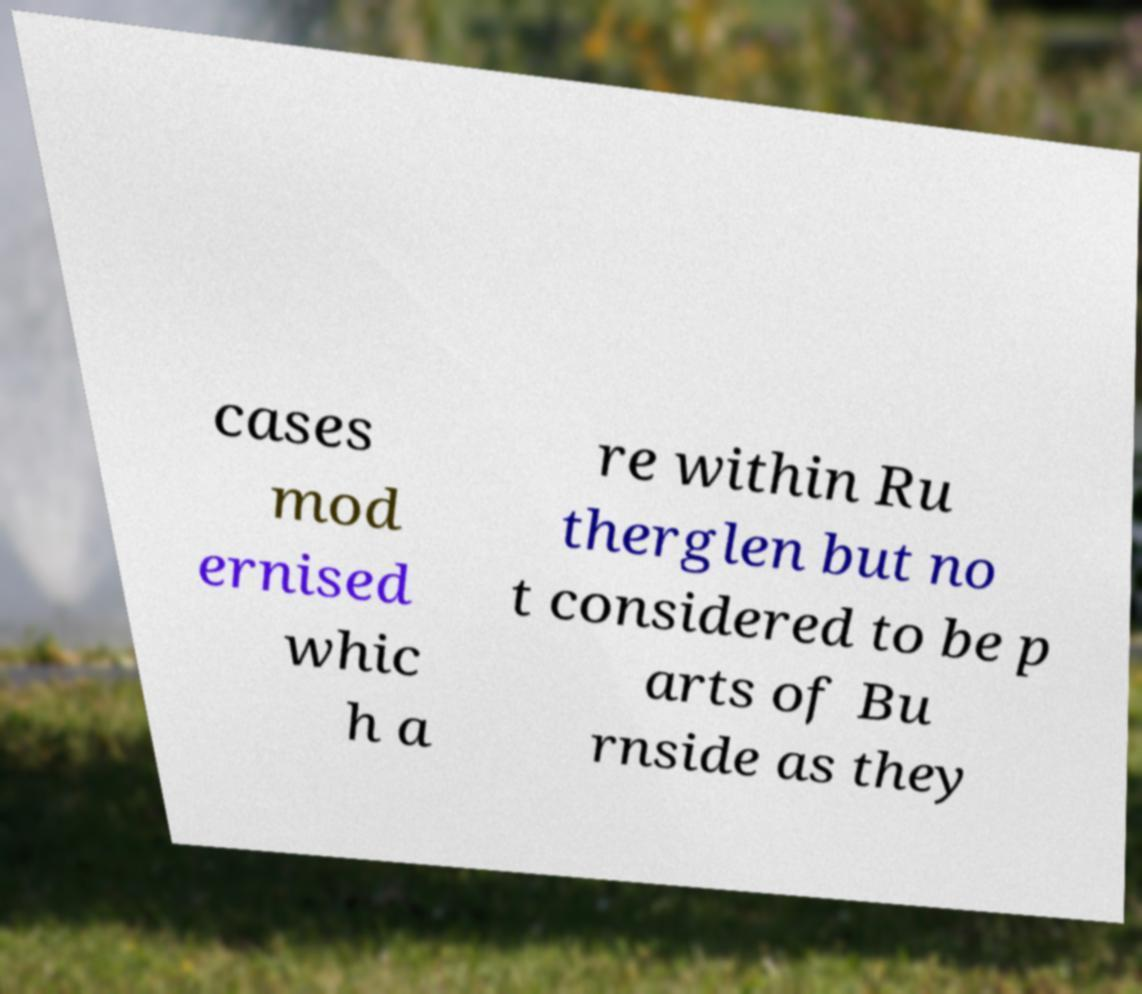Could you assist in decoding the text presented in this image and type it out clearly? cases mod ernised whic h a re within Ru therglen but no t considered to be p arts of Bu rnside as they 